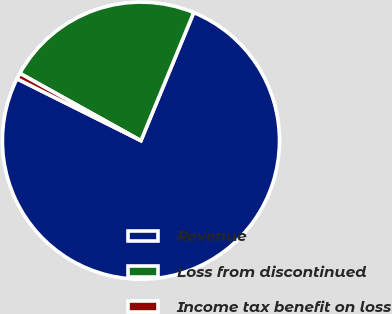Convert chart. <chart><loc_0><loc_0><loc_500><loc_500><pie_chart><fcel>Revenue<fcel>Loss from discontinued<fcel>Income tax benefit on loss<nl><fcel>76.15%<fcel>23.14%<fcel>0.71%<nl></chart> 